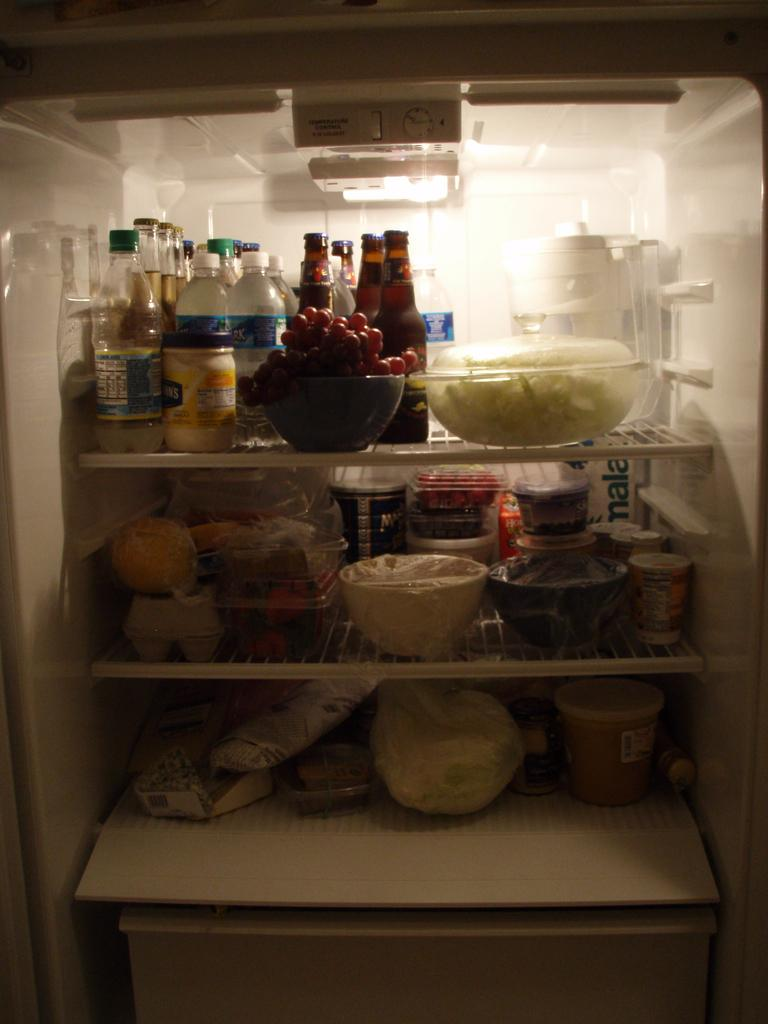<image>
Render a clear and concise summary of the photo. a dimly lit fridge with a container of helman's mayonnaise on the top shelf 